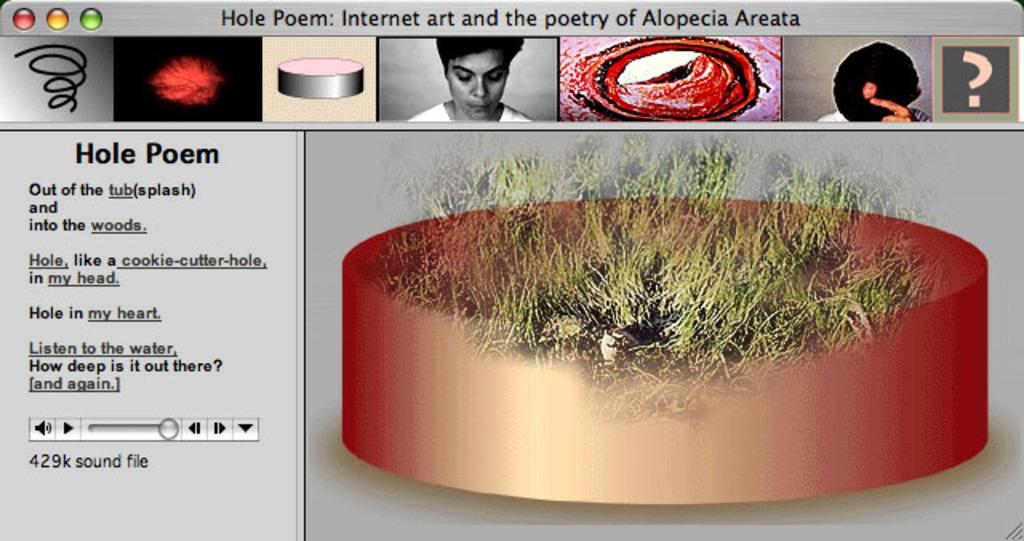What type of image is being shown? The image is a screenshot of a screen. What can be found within the screenshot? There is text and pictures in the image. How many rabbits are wearing a shirt in the image? There are no rabbits or shirts present in the image. 